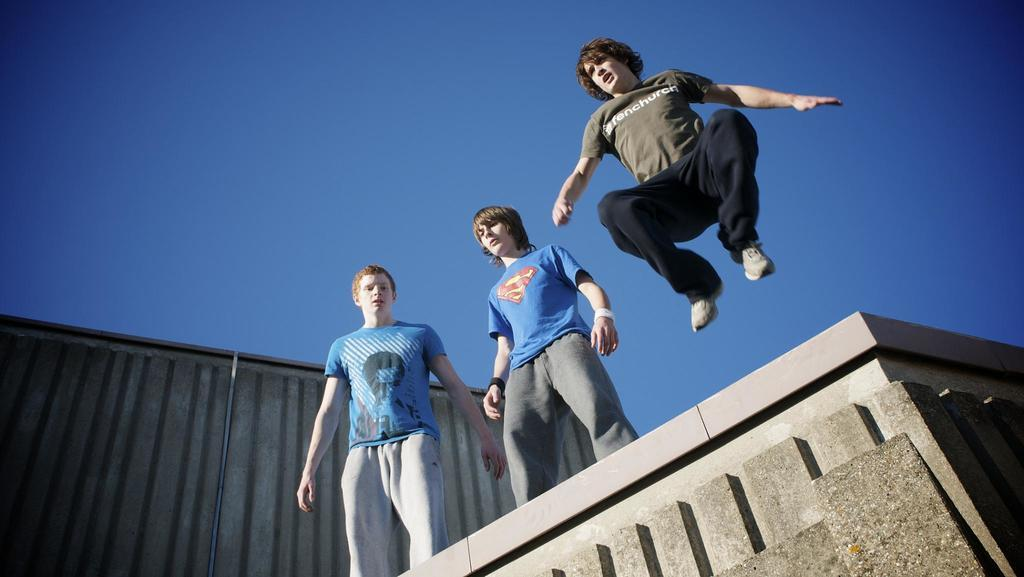How many people are in the image? There are three men in the image. What are the positions of the men in the image? One man is in the air, while the other two men are standing. What can be seen in the background of the image? The sky is visible in the background of the image. How many cars are parked on the coast in the image? There are no cars or coast visible in the image. 